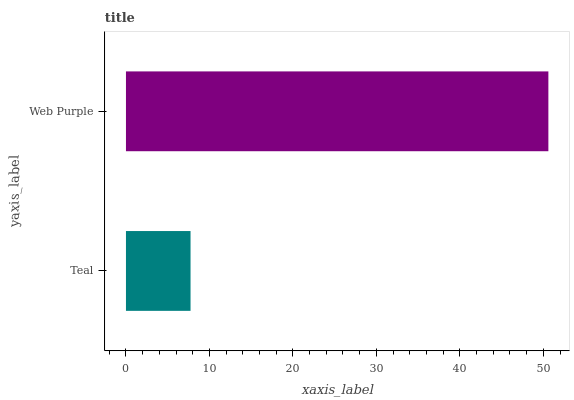Is Teal the minimum?
Answer yes or no. Yes. Is Web Purple the maximum?
Answer yes or no. Yes. Is Web Purple the minimum?
Answer yes or no. No. Is Web Purple greater than Teal?
Answer yes or no. Yes. Is Teal less than Web Purple?
Answer yes or no. Yes. Is Teal greater than Web Purple?
Answer yes or no. No. Is Web Purple less than Teal?
Answer yes or no. No. Is Web Purple the high median?
Answer yes or no. Yes. Is Teal the low median?
Answer yes or no. Yes. Is Teal the high median?
Answer yes or no. No. Is Web Purple the low median?
Answer yes or no. No. 